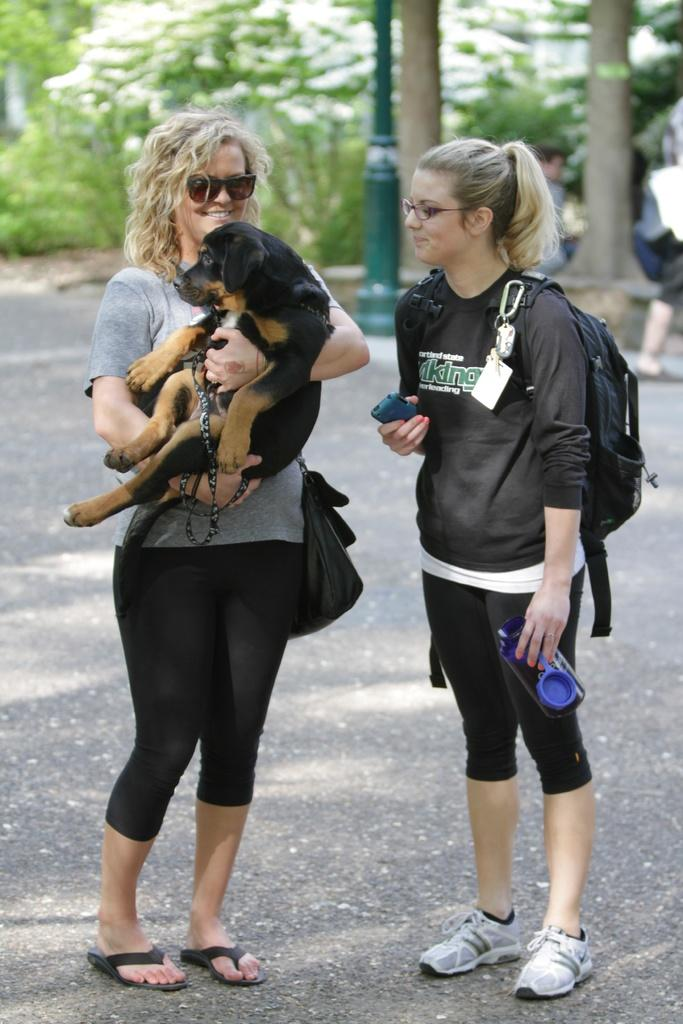How many women are in the image? There are two women in the image. What is the woman on the left holding? The woman on the left is holding a puppy. Can you describe the appearance of the woman holding the puppy? The woman holding the puppy is wearing spectacles. What can be seen in the background of the image? There are trees in the background of the image. What type of food is being served on the stage in the image? There is no stage or food present in the image. 